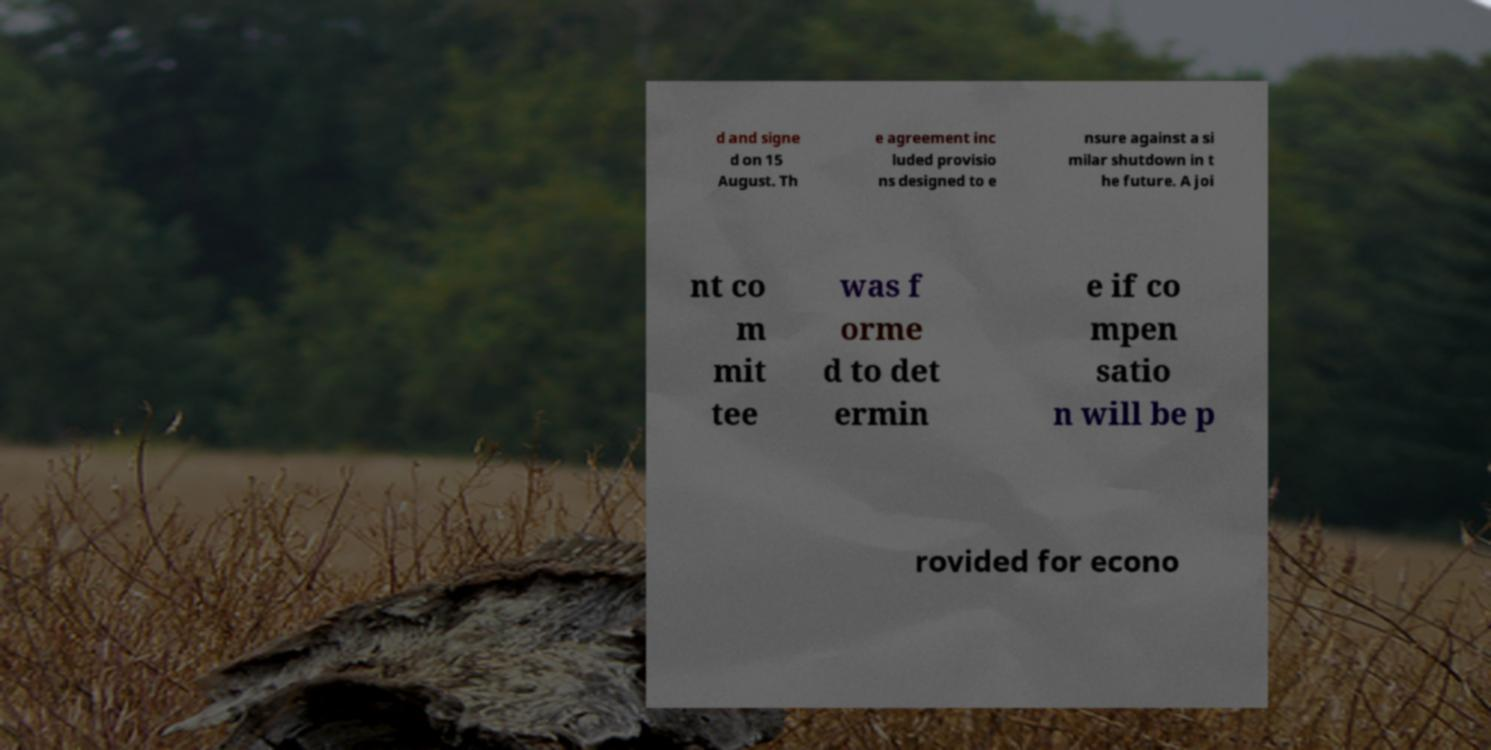Could you assist in decoding the text presented in this image and type it out clearly? d and signe d on 15 August. Th e agreement inc luded provisio ns designed to e nsure against a si milar shutdown in t he future. A joi nt co m mit tee was f orme d to det ermin e if co mpen satio n will be p rovided for econo 